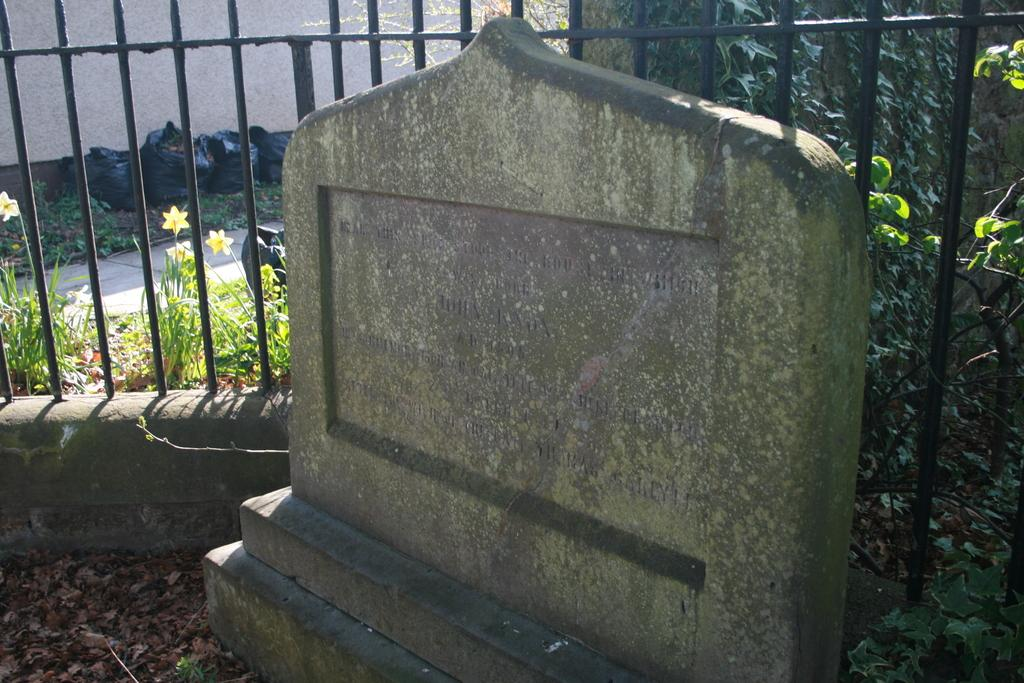What is the main object in the image with text on it? There is a stone with text in the image. What can be seen in the background of the image? There is a rail in the background of the image. What type of plants are present in the image? Flowers are present in the image. What type of covering is visible in the image? Polythene covers are visible in the image. What type of toothpaste is being used to mark the stone in the image? There is no toothpaste present in the image, nor is any marking being done on the stone. 